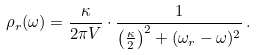Convert formula to latex. <formula><loc_0><loc_0><loc_500><loc_500>\rho _ { r } ( \omega ) = \frac { \kappa } { 2 \pi V } \cdot \frac { 1 } { \left ( \frac { \kappa } { 2 } \right ) ^ { 2 } + ( \omega _ { r } - \omega ) ^ { 2 } } \, .</formula> 